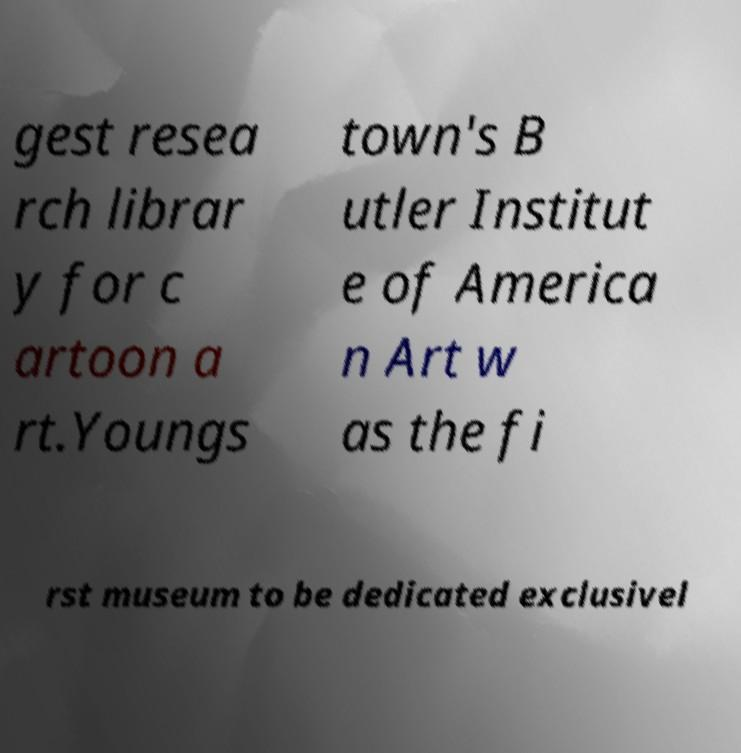I need the written content from this picture converted into text. Can you do that? gest resea rch librar y for c artoon a rt.Youngs town's B utler Institut e of America n Art w as the fi rst museum to be dedicated exclusivel 